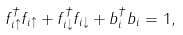Convert formula to latex. <formula><loc_0><loc_0><loc_500><loc_500>f _ { i \uparrow } ^ { \dagger } f _ { i \uparrow } + f _ { i \downarrow } ^ { \dagger } f _ { i \downarrow } + b ^ { \dagger } _ { i } b _ { i } = 1 ,</formula> 